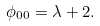<formula> <loc_0><loc_0><loc_500><loc_500>\phi _ { 0 0 } = \lambda + 2 .</formula> 